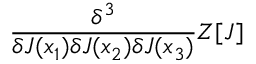<formula> <loc_0><loc_0><loc_500><loc_500>{ \frac { \delta ^ { 3 } } { \delta J ( x _ { 1 } ) \delta J ( x _ { 2 } ) \delta J ( x _ { 3 } ) } } Z [ J ]</formula> 